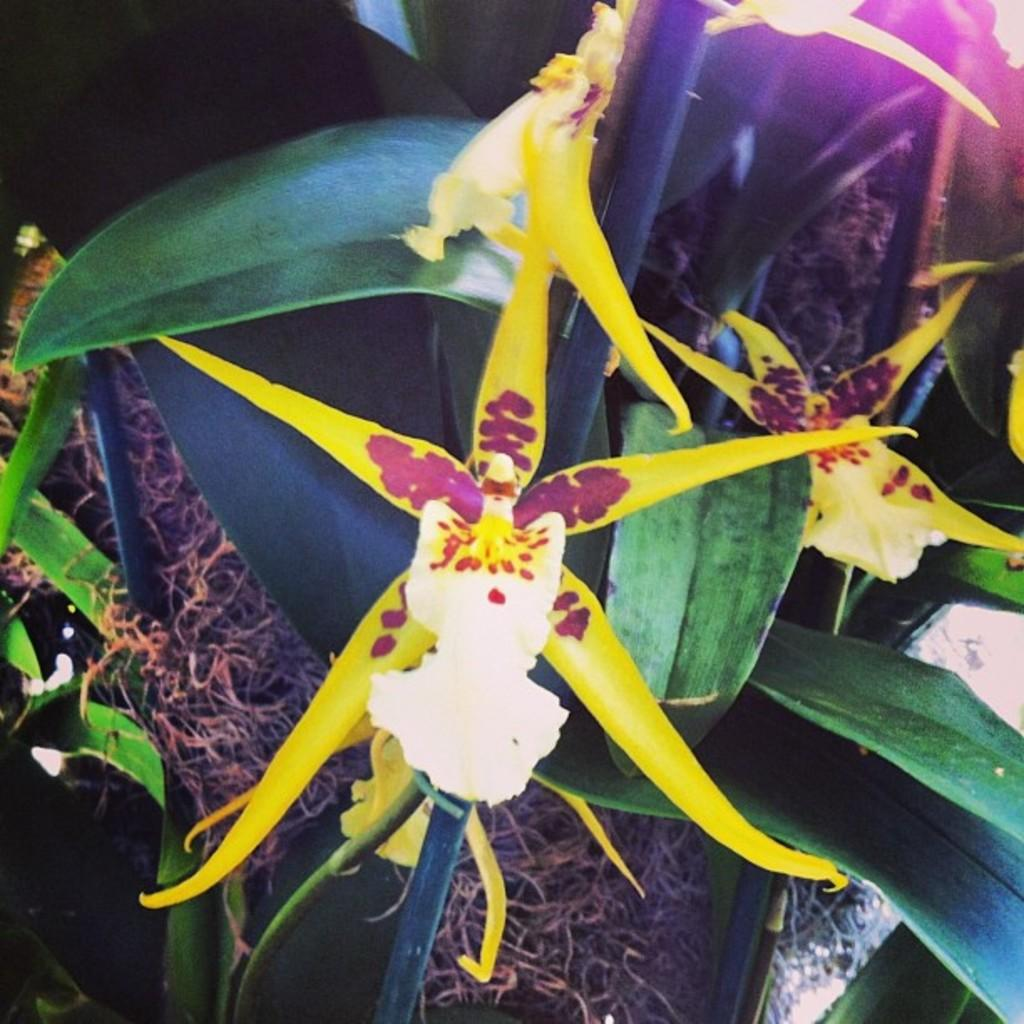What type of living organisms can be seen in the image? Plants can be seen in the image. What specific feature of the plants is visible in the image? The plants have flowers. What type of battle is depicted in the image? There is no battle depicted in the image; it features plants with flowers. What type of rose can be seen in the image? There is no rose present in the image; the plants have unspecified flowers. 